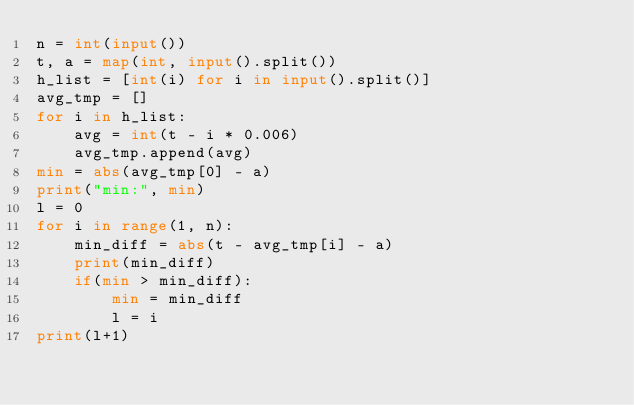<code> <loc_0><loc_0><loc_500><loc_500><_Python_>n = int(input())
t, a = map(int, input().split())
h_list = [int(i) for i in input().split()]
avg_tmp = []
for i in h_list:
    avg = int(t - i * 0.006)
    avg_tmp.append(avg)
min = abs(avg_tmp[0] - a)
print("min:", min)
l = 0
for i in range(1, n):
    min_diff = abs(t - avg_tmp[i] - a)
    print(min_diff)
    if(min > min_diff):
        min = min_diff
        l = i
print(l+1)</code> 